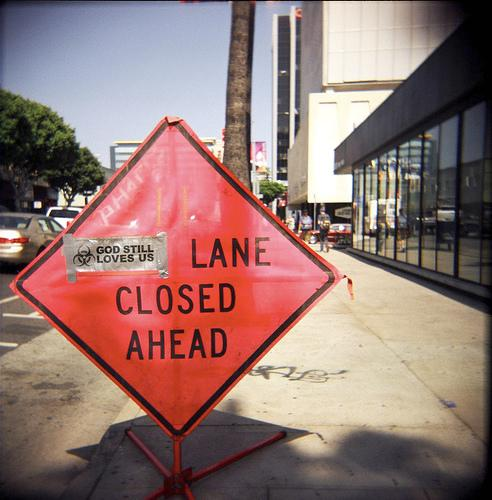How was something added to this sign most recently?

Choices:
A) nailed
B) tape
C) ironed on
D) painted tape 